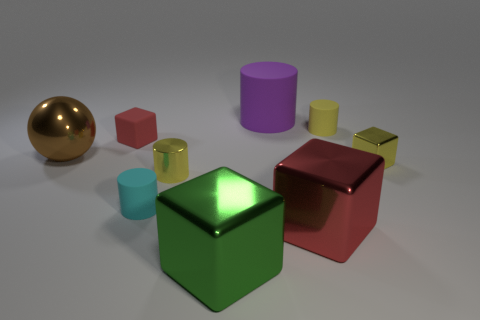Add 1 yellow shiny blocks. How many objects exist? 10 Subtract all cylinders. How many objects are left? 5 Add 7 large green cylinders. How many large green cylinders exist? 7 Subtract 0 blue cylinders. How many objects are left? 9 Subtract all small matte cylinders. Subtract all big purple rubber things. How many objects are left? 6 Add 8 green blocks. How many green blocks are left? 9 